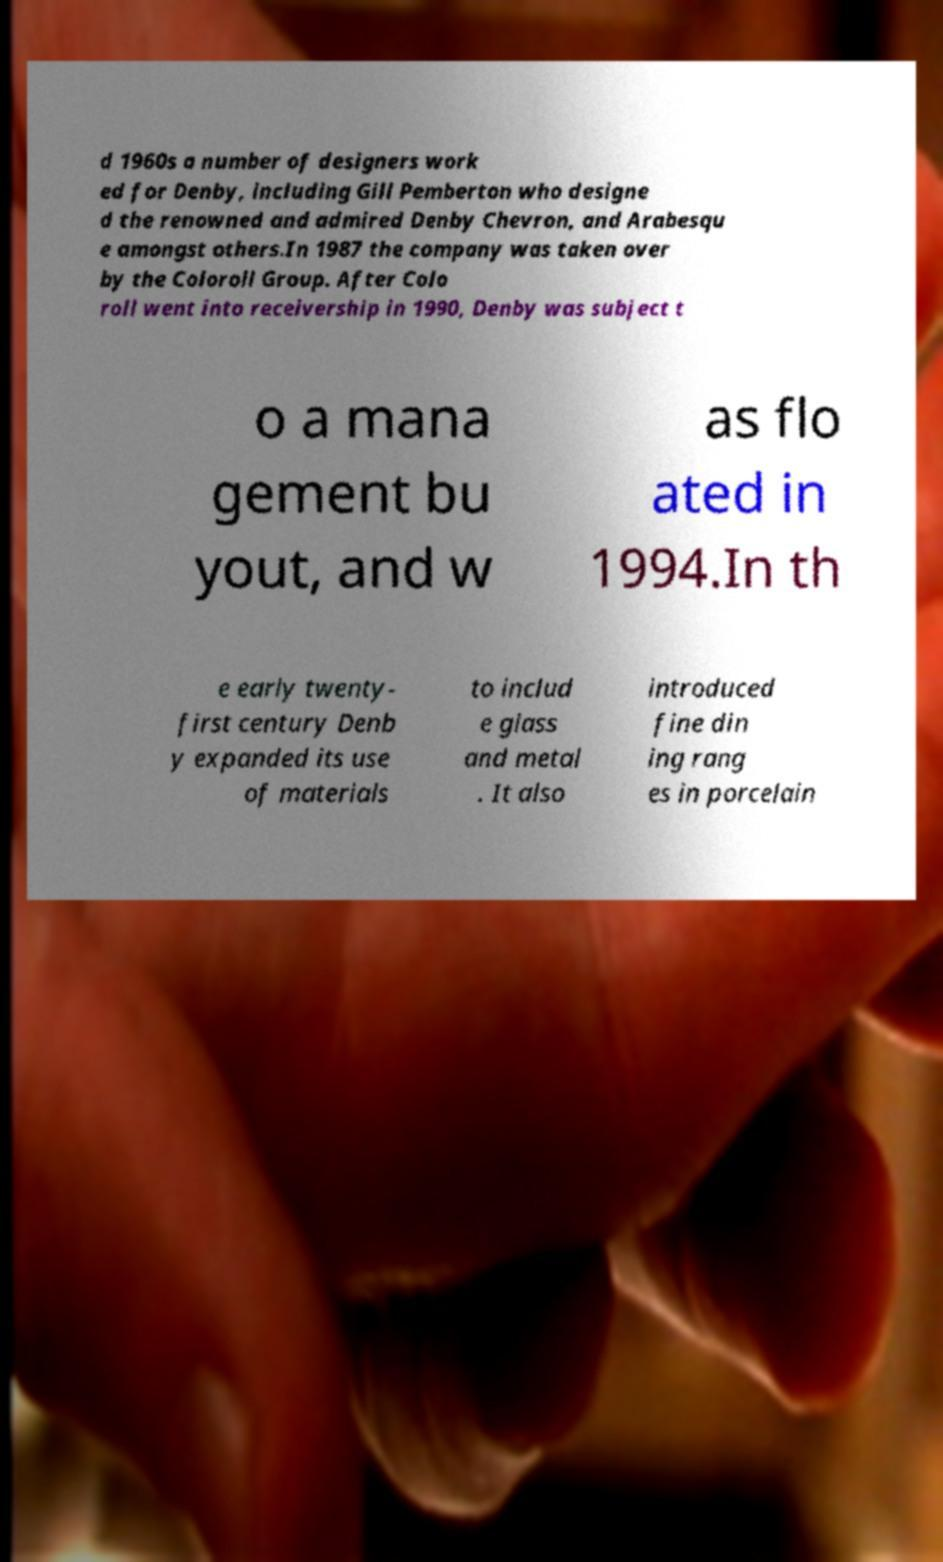For documentation purposes, I need the text within this image transcribed. Could you provide that? d 1960s a number of designers work ed for Denby, including Gill Pemberton who designe d the renowned and admired Denby Chevron, and Arabesqu e amongst others.In 1987 the company was taken over by the Coloroll Group. After Colo roll went into receivership in 1990, Denby was subject t o a mana gement bu yout, and w as flo ated in 1994.In th e early twenty- first century Denb y expanded its use of materials to includ e glass and metal . It also introduced fine din ing rang es in porcelain 